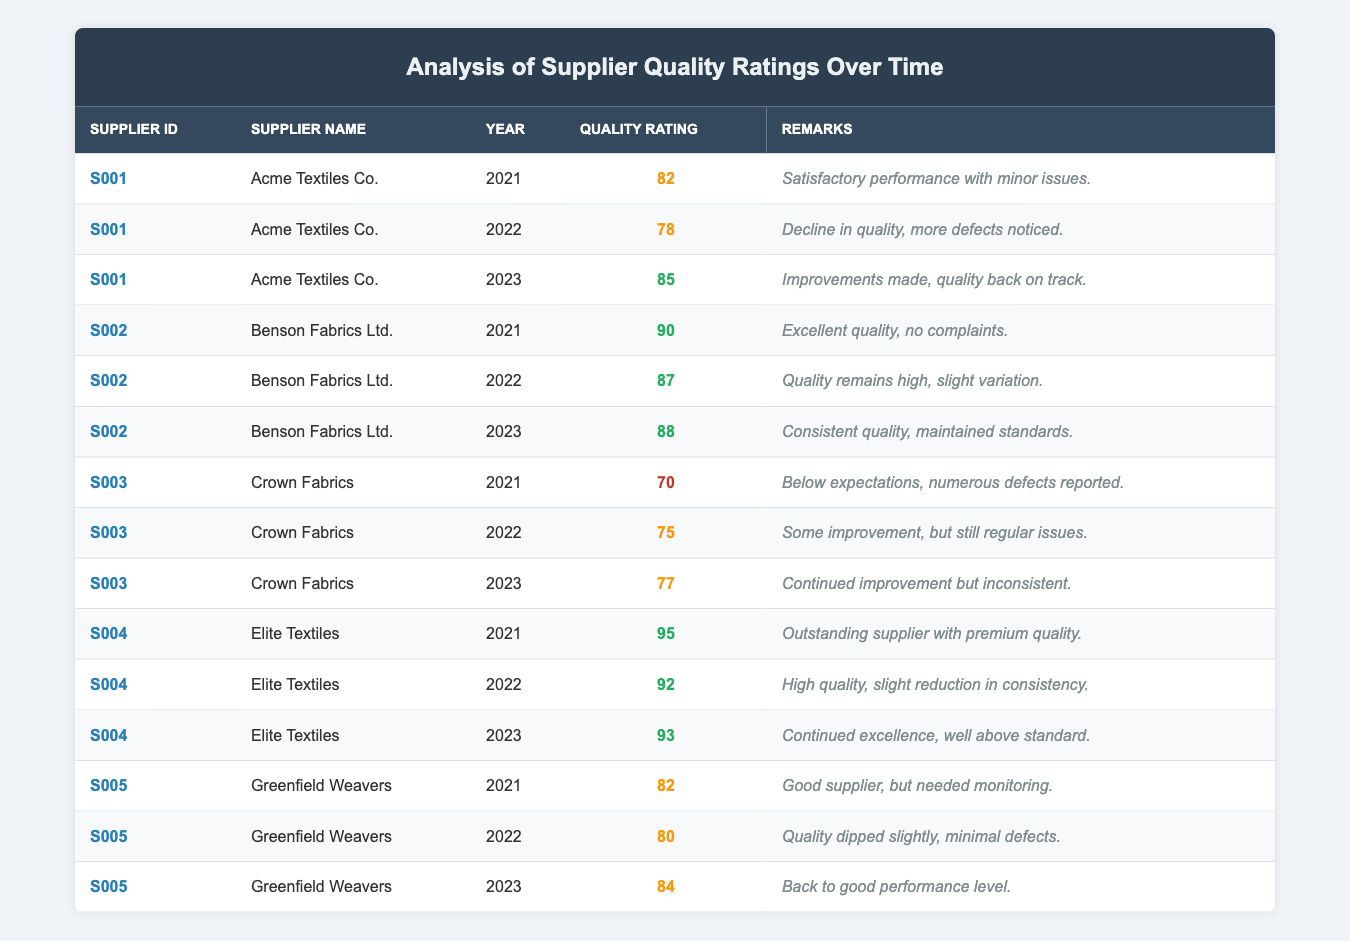What was the highest quality rating received by any supplier in 2021? Looking at the Quality Rating column for the year 2021, the highest rating is 95, which belongs to Elite Textiles.
Answer: 95 Which supplier showed a decline in quality ratings from 2021 to 2022? By comparing the Quality Ratings for each supplier from 2021 to 2022, Acme Textiles Co. went from 82 in 2021 to 78 in 2022, indicating a decline.
Answer: Acme Textiles Co Did any supplier maintain the same quality rating across the three years? On examining each supplier's ratings over the three years, all suppliers showed changes in their ratings; thus, no supplier maintained a consistent rating.
Answer: No What is the average quality rating of Crown Fabrics between 2021 and 2023? To find the average, we sum the ratings for Crown Fabrics: (70 + 75 + 77) = 222. Next, we divide by the number of years, which is 3. Therefore, 222/3 = 74.
Answer: 74 Which supplier had the most consistent quality ratings across the years? Assessing the ratings, Benson Fabrics Ltd. had ratings of 90, 87, and 88 over three years, with minimal fluctuations. Other suppliers had larger variations in their scores.
Answer: Benson Fabrics Ltd Was there an improvement in the quality rating for Greenfield Weavers from 2022 to 2023? Greenfield Weavers rated 80 in 2022 and improved to 84 in 2023, indicating a positive change in quality performance.
Answer: Yes What was the change in quality rating for Elite Textiles from 2021 to 2023? Elite Textiles had a rating of 95 in 2021 and a rating of 93 in 2023. The change is a decrease of 2 points from 2021 to 2023.
Answer: Decrease of 2 points Which supplier had the lowest average quality rating over the three years? Calculating the averages shows that Crown Fabrics (70, 75, 77) has an average of 74, which is lower than all others. Therefore, it has the lowest average quality rating.
Answer: Crown Fabrics How many suppliers had a quality rating above 85 in 2023? Reviewing the 2023 ratings, Elite Textiles (93), Benson Fabrics Ltd. (88), and Acme Textiles Co. (85) all ranked above 85, making a total of 3 suppliers.
Answer: 3 